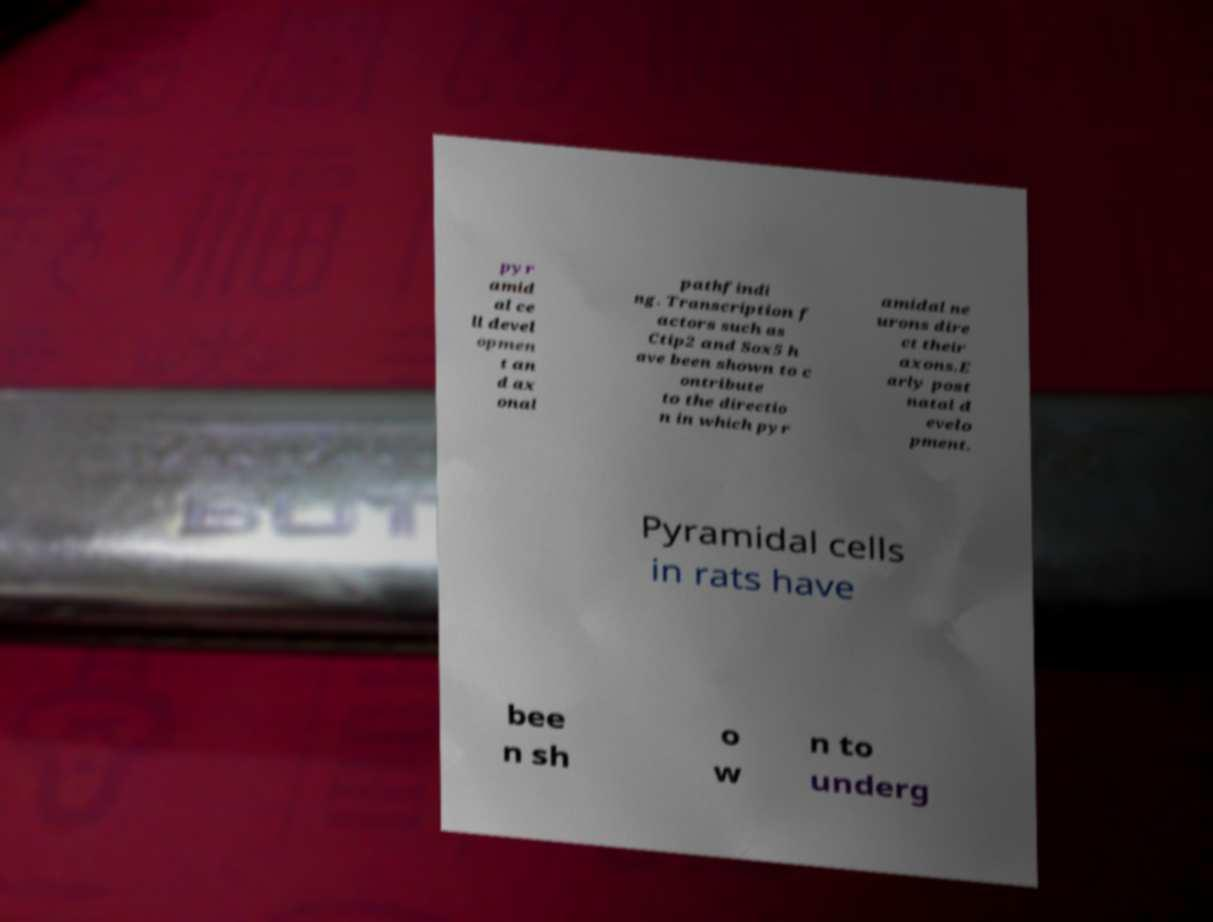Please identify and transcribe the text found in this image. pyr amid al ce ll devel opmen t an d ax onal pathfindi ng. Transcription f actors such as Ctip2 and Sox5 h ave been shown to c ontribute to the directio n in which pyr amidal ne urons dire ct their axons.E arly post natal d evelo pment. Pyramidal cells in rats have bee n sh o w n to underg 